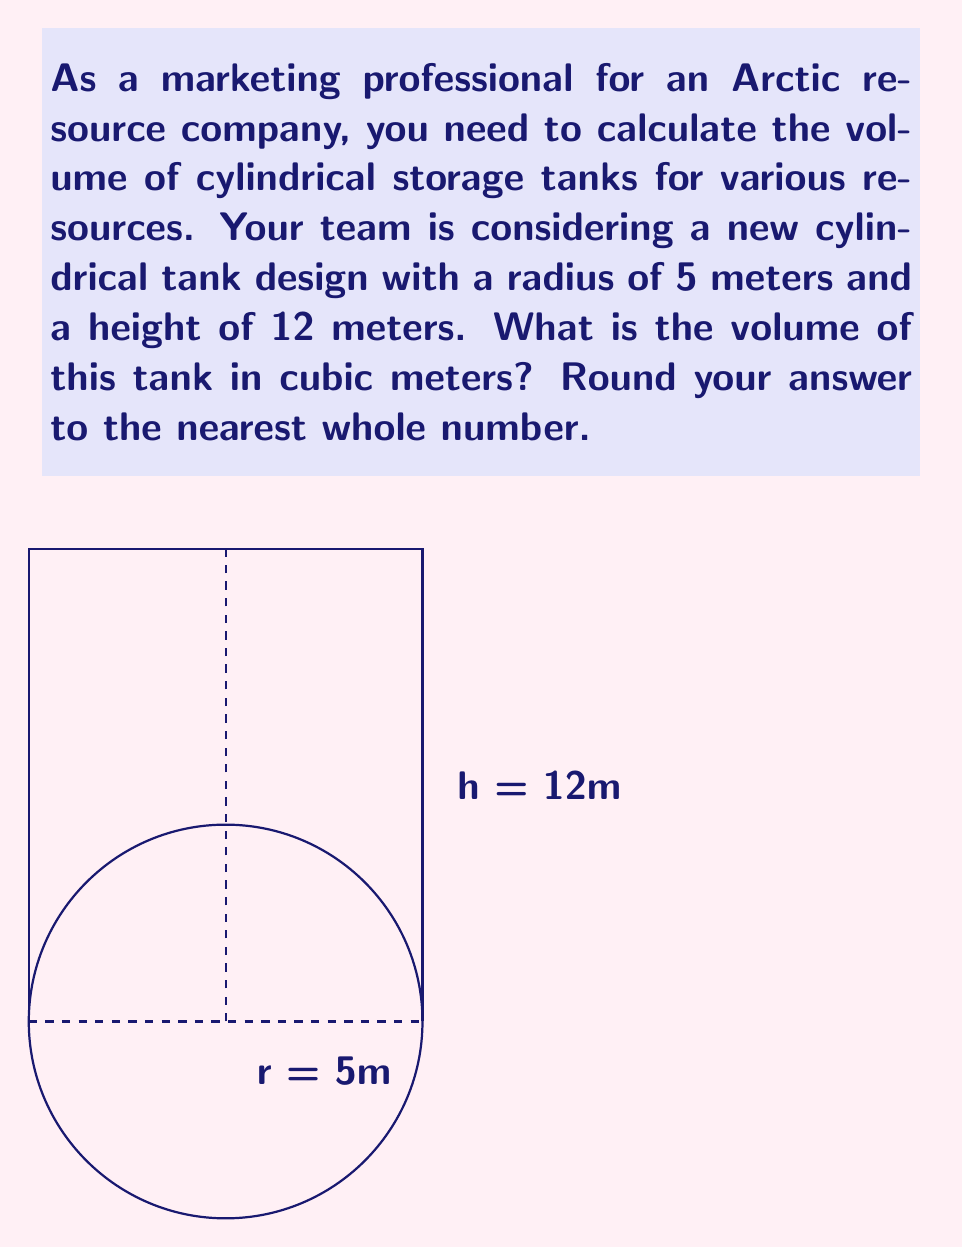Can you answer this question? To calculate the volume of a cylindrical tank, we use the formula:

$$V = \pi r^2 h$$

Where:
$V$ = volume
$r$ = radius of the base
$h$ = height of the cylinder

Given:
$r = 5$ meters
$h = 12$ meters

Let's substitute these values into the formula:

$$V = \pi (5\text{ m})^2 (12\text{ m})$$

Simplify:
$$V = \pi (25\text{ m}^2) (12\text{ m})$$
$$V = 300\pi\text{ m}^3$$

Using $\pi \approx 3.14159$, we get:

$$V \approx 300 \times 3.14159\text{ m}^3$$
$$V \approx 942.48\text{ m}^3$$

Rounding to the nearest whole number:

$$V \approx 942\text{ m}^3$$
Answer: 942 m³ 